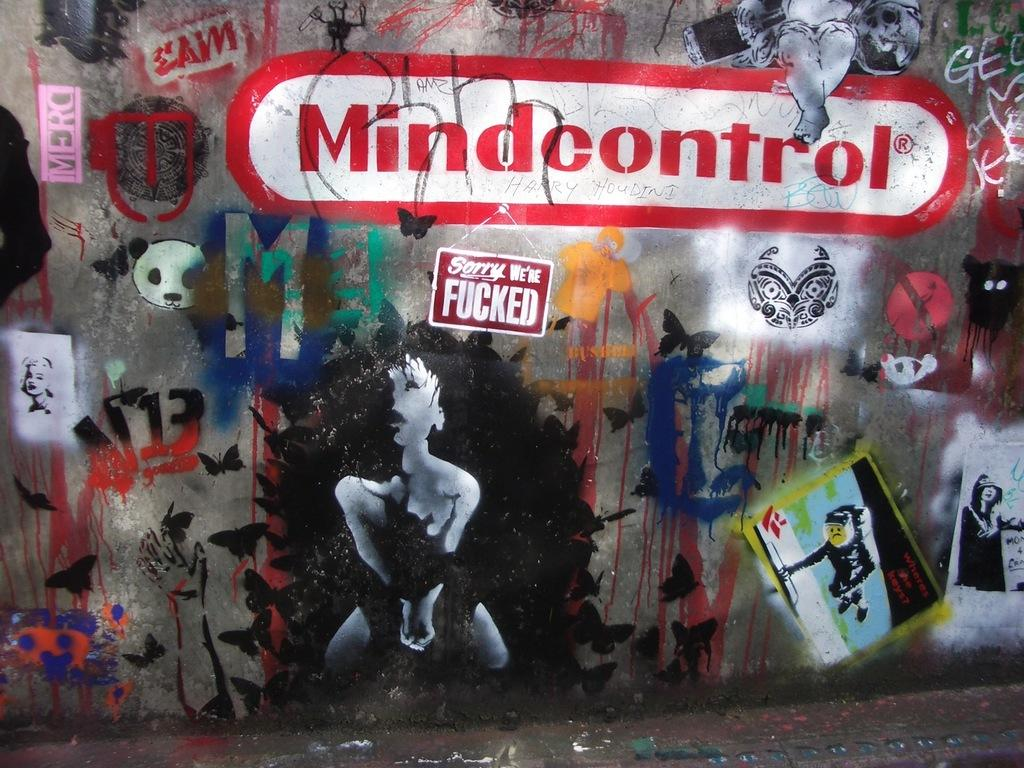What can be seen in the image? There is a wall in the image. What is on the wall? There is graffiti on the wall. What does the graffiti taste like in the image? The graffiti cannot be tasted in the image, as it is a visual representation and not a physical object. 